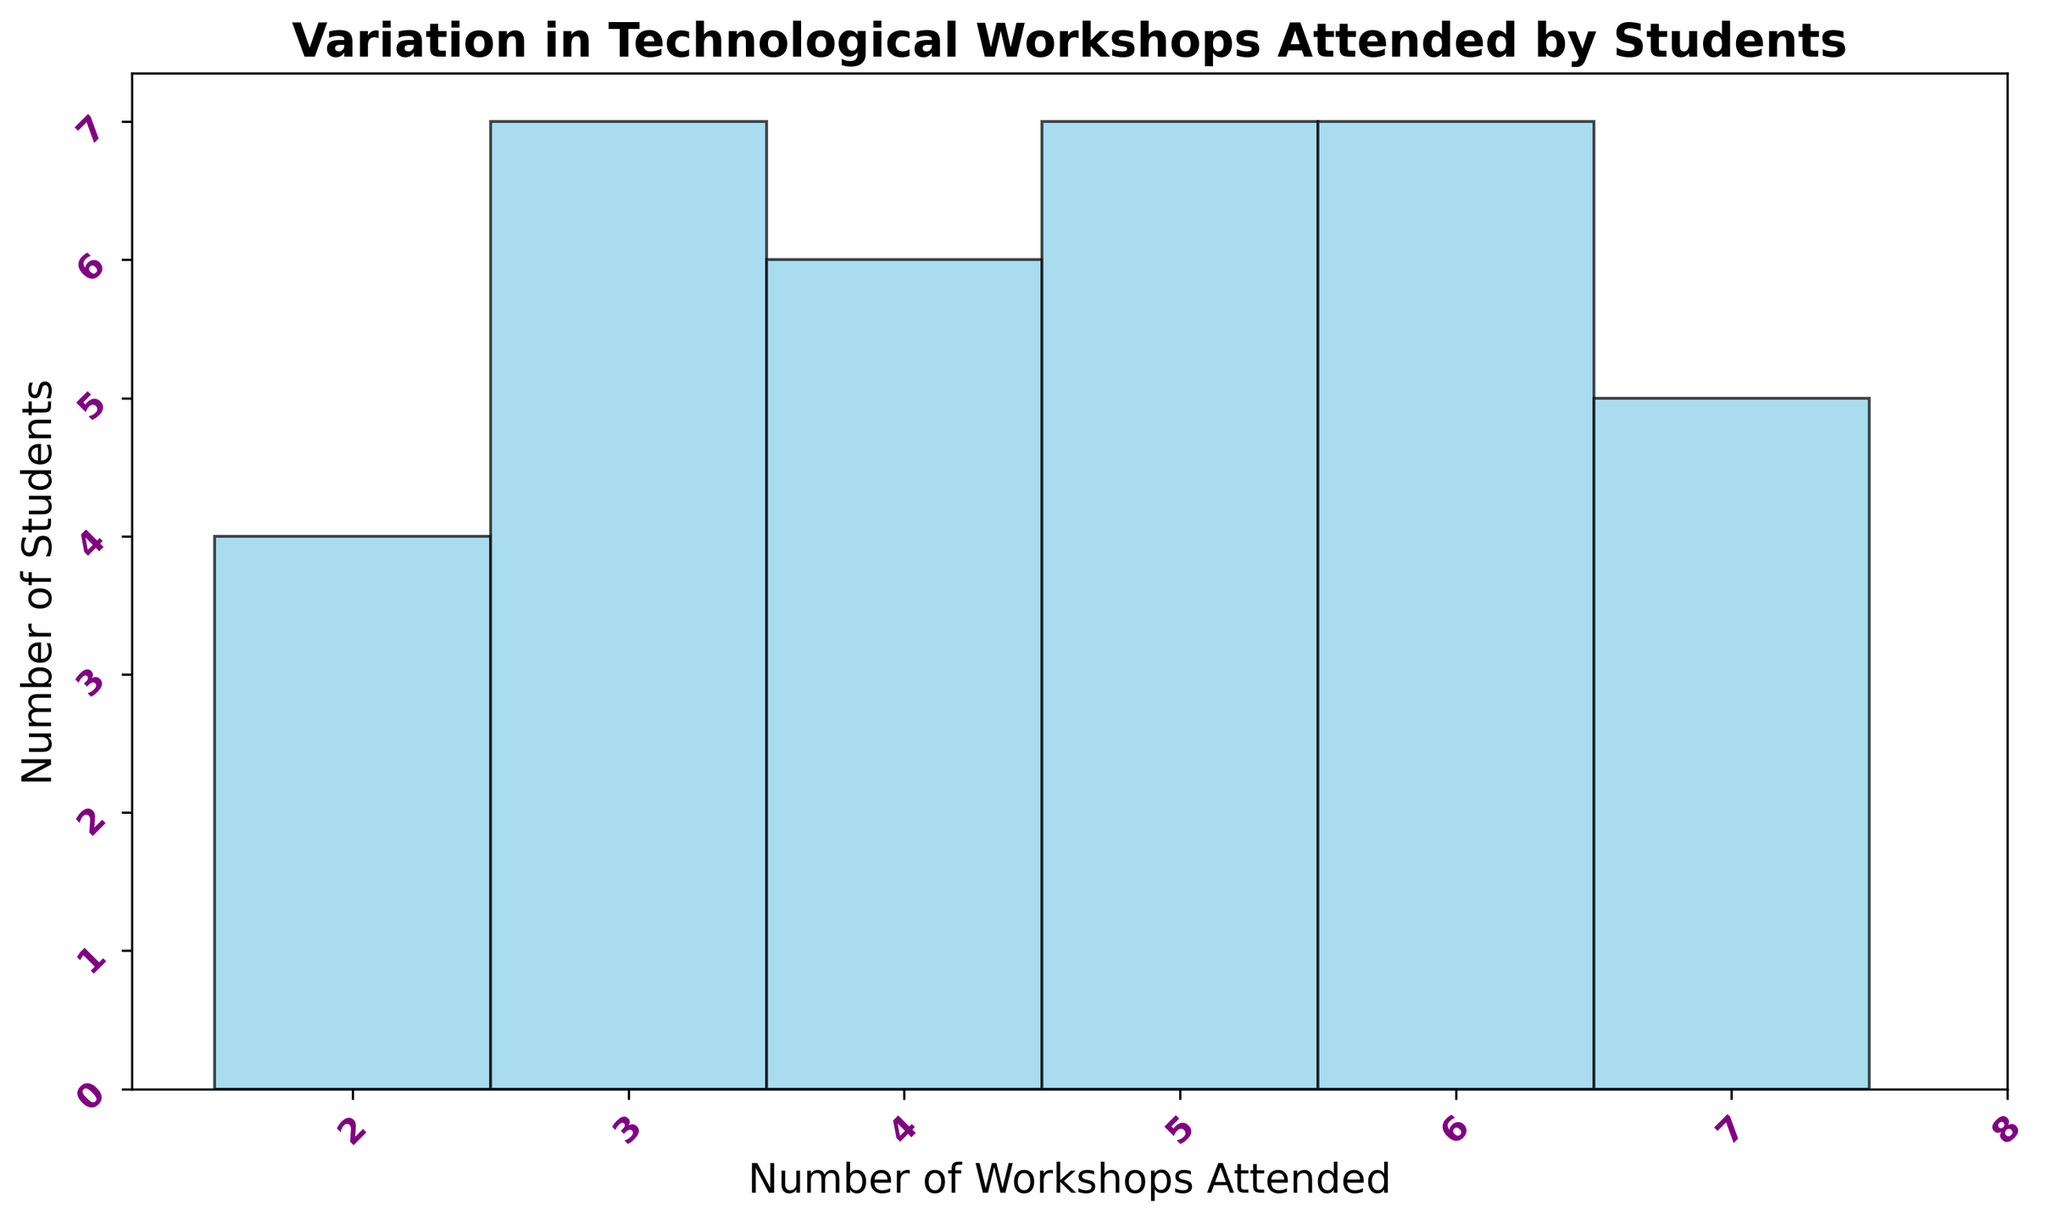How many students attended 6 workshops? There is a bar representing the number of students who attended 6 workshops. By looking at the height of that bar, we can count them.
Answer: 6 Which number of workshops attended had the highest number of students? By comparing the heights of all the bars, we can identify which bar is the tallest. The tallest bar represents the number of workshops with the highest number of students.
Answer: 5 How many students attended between 4 and 7 workshops inclusive? To find this, add the heights of the bars for 4, 5, 6, and 7 workshops. Each bar height represents the number of students for that specific number of workshops.
Answer: 23 Are there more students who attended less than 4 workshops or more than 6 workshops? Count the heights of the bars for workshops less than 4 (2, 3) and more than 6 (7, 8). Compare the sums of these groups.
Answer: Less than 4 What's the range of workshops attended by students? The range is the difference between the highest and lowest number of workshops attended. Identify the maximum and minimum values on the x-axis.
Answer: 6 Which specific number of workshops attended is least common among students? Find the bar with the lowest height. This height represents the least common number of workshops attended.
Answer: 2 How many more students attended 5 workshops than 3 workshops? Subtract the height of the bar representing 3 workshops from the height of the bar representing 5 workshops.
Answer: 3 What is the average number of workshops attended by students? Sum the data points (total workshops attended) and divide by the number of students (total data points).
Answer: 5 What is the median number of workshops attended by students? List all the data points in order and find the middle one. If you have an even number of data points, average the two middle ones.
Answer: 5 Which number of workshops attended by students appears more frequently than attending 4 workshops but less frequently than 8 workshops? Identify the height of the bar representing 4 workshops and find bars that are taller than this but shorter than the bar representing 8 workshops.
Answer: 6 